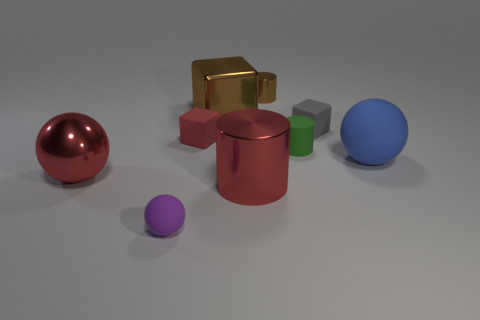Is there any indication of the scale or size of these objects? Without a familiar reference object to compare, it's difficult to ascertain the exact scale of the objects. However, judging by the relative sizes and the shadows they cast, one might imagine these objects as small-scale models that could comfortably fit on a desk or table. 